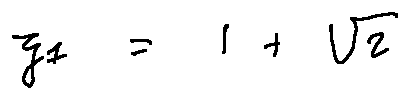Convert formula to latex. <formula><loc_0><loc_0><loc_500><loc_500>z _ { 1 } = 1 + \sqrt { 2 }</formula> 